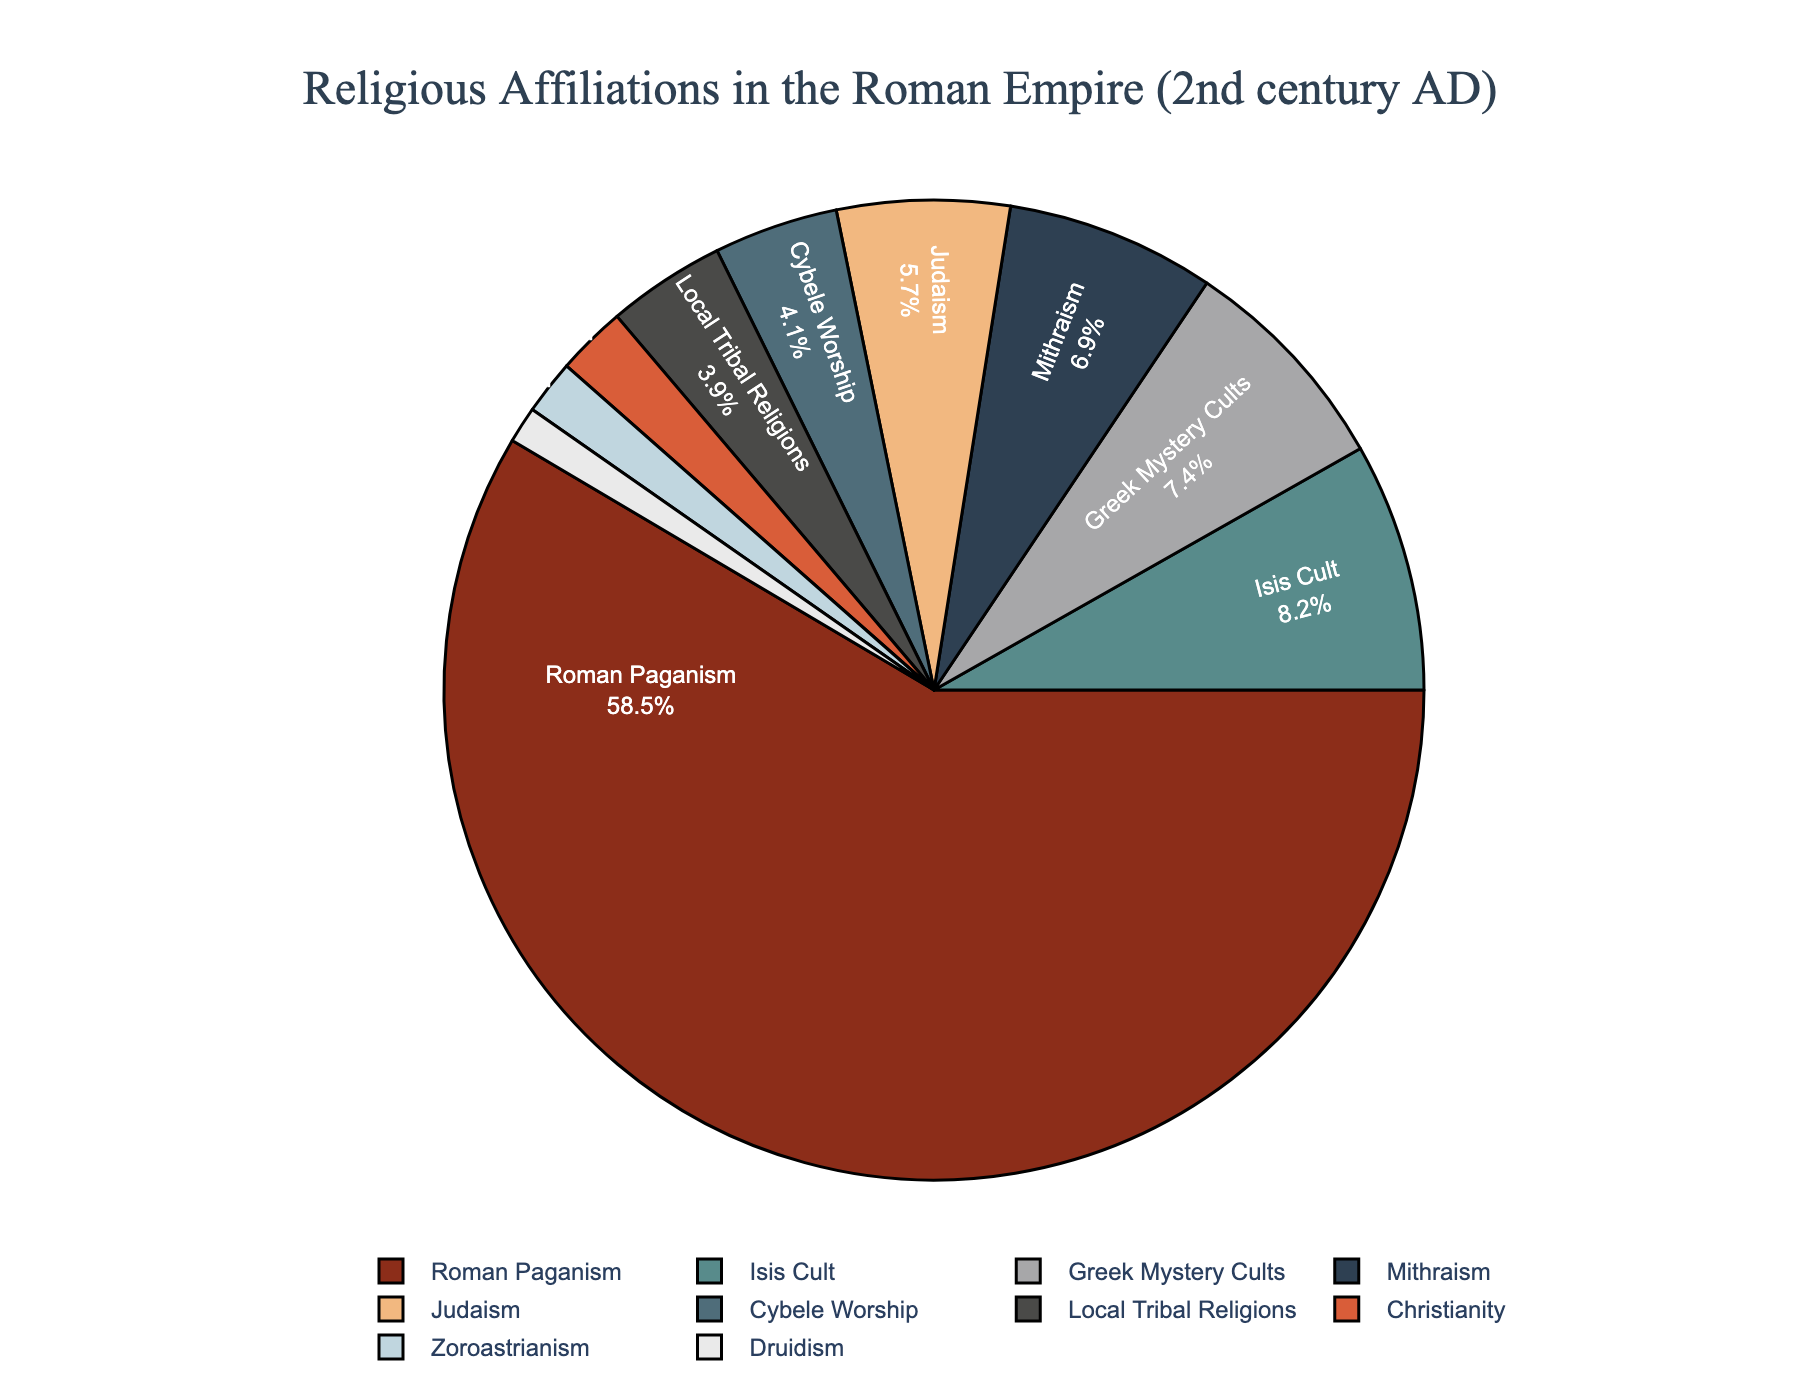What percentage of the population practiced Christianity? Look at the pie chart and find the segment labeled "Christianity." The percentage value indicated for Christianity is 2.3%.
Answer: 2.3% Which was more popular in the Roman Empire: Judaism or Mithraism? Identify the segments labeled "Judaism" and "Mithraism." The percentage for Judaism is 5.7%, and for Mithraism, it is 6.9%. Comparing these values shows that Mithraism was more popular.
Answer: Mithraism What are the combined percentages of Roman Paganism and the Greek Mystery Cults? Find the segments for "Roman Paganism" and "Greek Mystery Cults." The percentage for Roman Paganism is 58.5%, and for Greek Mystery Cults, it is 7.4%. Adding these gives 58.5% + 7.4% = 65.9%.
Answer: 65.9% Which religion had a smaller following, Zoroastrianism or Druidism? Identify the segments for "Zoroastrianism" and "Druidism." The percentage for Zoroastrianism is 1.8%, and for Druidism, it is 1.2%. Therefore, Druidism had a smaller following.
Answer: Druidism What is the difference in percentages between the Isis Cult and Cybele Worship? Find the segments for "Isis Cult" and "Cybele Worship." The percentage for Isis Cult is 8.2%, and for Cybele Worship, it is 4.1%. The difference is 8.2% - 4.1% = 4.1%.
Answer: 4.1% Consider the religions with percentages greater than 5%. What is the total percentage for these religions? The segments with percentages greater than 5% are "Roman Paganism" (58.5%), "Judaism" (5.7%), "Isis Cult" (8.2%), "Mithraism" (6.9%), and "Greek Mystery Cults" (7.4%). Summing these gives 58.5% + 5.7% + 8.2% + 6.9% + 7.4% = 86.7%.
Answer: 86.7% Which religion has the darkest color on the pie chart? Observe the pie chart and look for the segment with the darkest shade. The darkest segment corresponds to "Roman Paganism."
Answer: Roman Paganism If the percentage of Christianity doubled, what would the new percentage be? The current percentage for Christianity is 2.3%. Doubling this gives 2.3% * 2 = 4.6%.
Answer: 4.6% What is the average percentage of Judaism, Isis Cult, and Mithraism? The percentages for "Judaism" (5.7%), "Isis Cult" (8.2%), and "Mithraism" (6.9%) are provided. Adding these gives 5.7% + 8.2% + 6.9% = 20.8%, and dividing by 3, the number of religions, gives 20.8% / 3 ≈ 6.93%.
Answer: 6.93% How much larger is the percentage of Roman Paganism compared to Local Tribal Religions? The percentage for "Roman Paganism" is 58.5%, and for "Local Tribal Religions," it is 3.9%. The difference is 58.5% - 3.9% = 54.6%.
Answer: 54.6% 